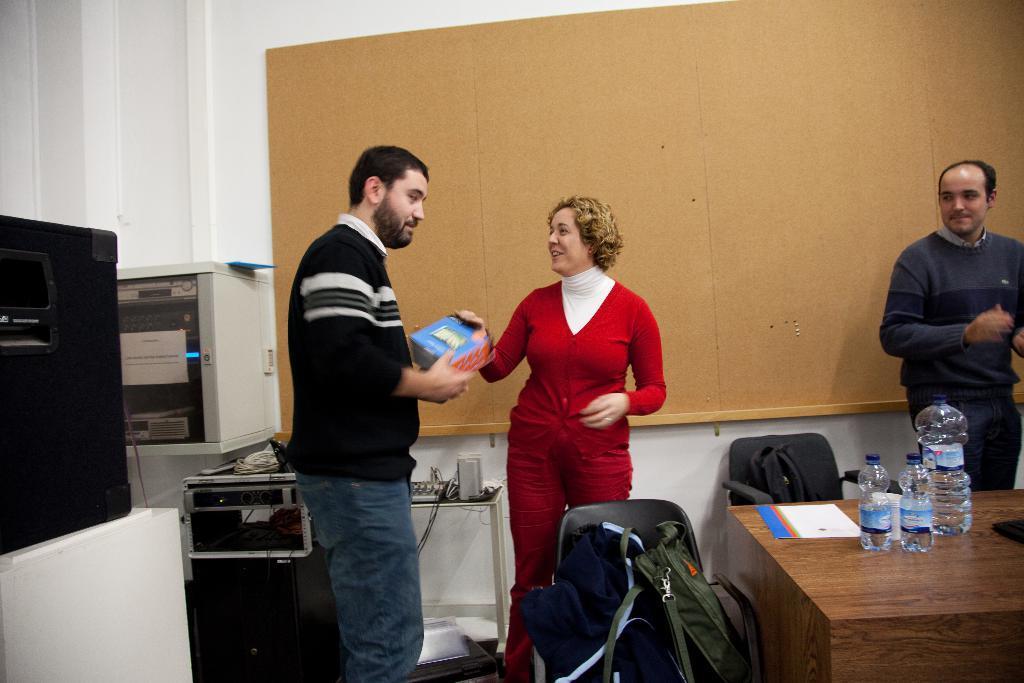Describe this image in one or two sentences. In the image we can see there are people standing and there are bags kept on the chair. There are water bottles kept on the table and there is a man holding books in his hand. There are other machines kept on the table. 